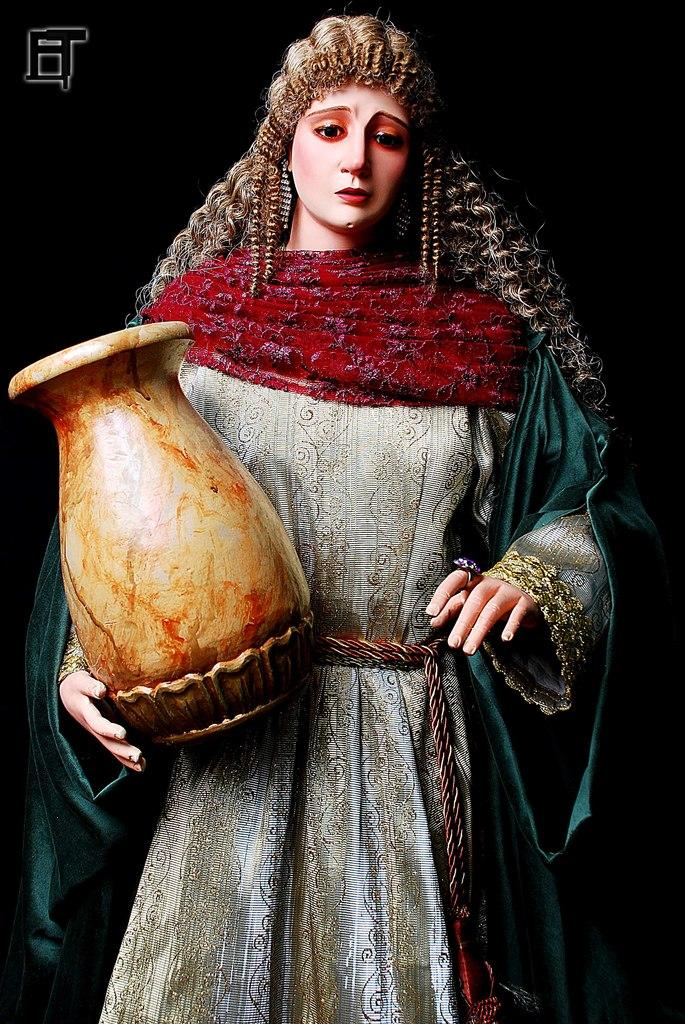Who is the main subject in the image? There is a woman in the image. What is the woman holding in the image? The woman is holding a pot. Can you describe the background of the image? The background of the image is dark. Is there any text or symbol in the image? Yes, there is a logo in the top left corner of the image. Can you hear the woman crying in the image? There is no sound in the image, so it is not possible to hear the woman crying. 